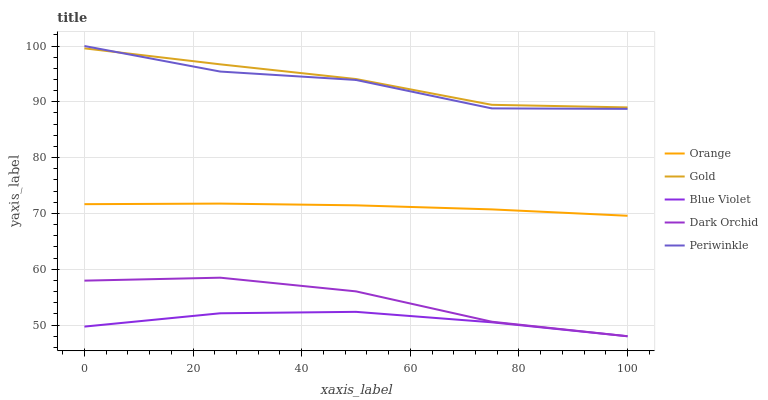Does Dark Orchid have the minimum area under the curve?
Answer yes or no. No. Does Dark Orchid have the maximum area under the curve?
Answer yes or no. No. Is Dark Orchid the smoothest?
Answer yes or no. No. Is Dark Orchid the roughest?
Answer yes or no. No. Does Periwinkle have the lowest value?
Answer yes or no. No. Does Dark Orchid have the highest value?
Answer yes or no. No. Is Blue Violet less than Periwinkle?
Answer yes or no. Yes. Is Periwinkle greater than Blue Violet?
Answer yes or no. Yes. Does Blue Violet intersect Periwinkle?
Answer yes or no. No. 